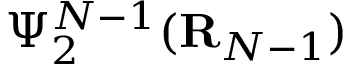<formula> <loc_0><loc_0><loc_500><loc_500>\Psi _ { 2 } ^ { N - 1 } ( { R } _ { N - 1 } )</formula> 